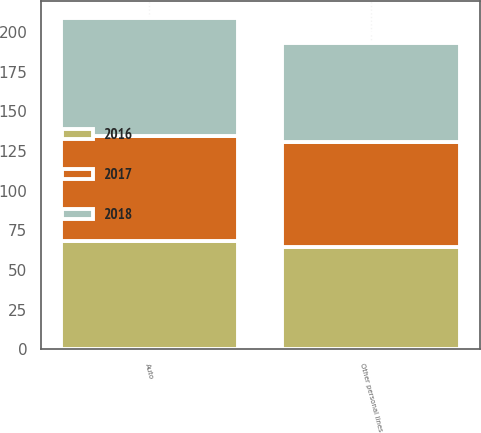<chart> <loc_0><loc_0><loc_500><loc_500><stacked_bar_chart><ecel><fcel>Auto<fcel>Other personal lines<nl><fcel>2017<fcel>66.2<fcel>66.5<nl><fcel>2016<fcel>68.1<fcel>64.3<nl><fcel>2018<fcel>74.5<fcel>62<nl></chart> 